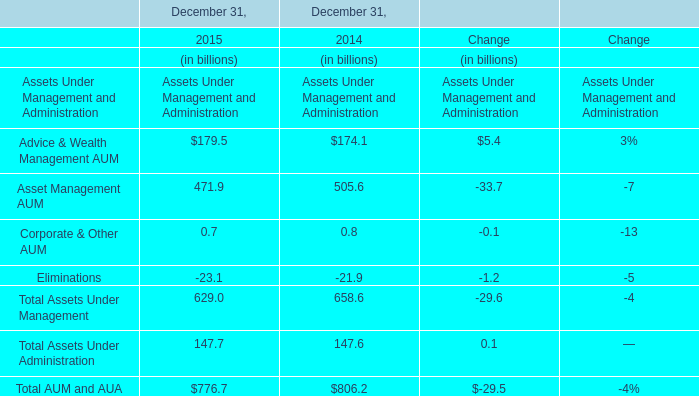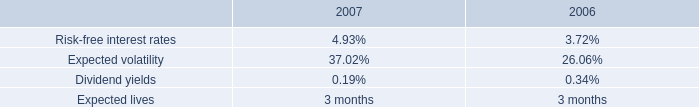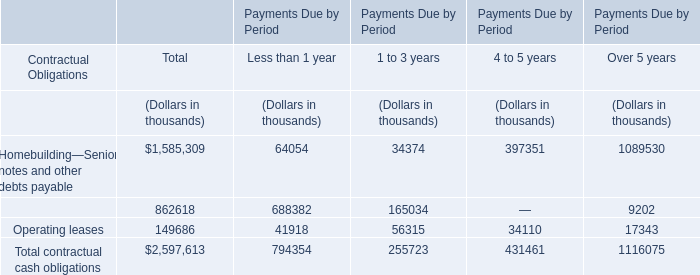What will Asset Management AUM be like in 2016 if it continues to grow at the same rate as it did in 2015? (in billion) 
Computations: ((1 + ((471.9 - 505.6) / 505.6)) * 471.9)
Answer: 440.44622. 